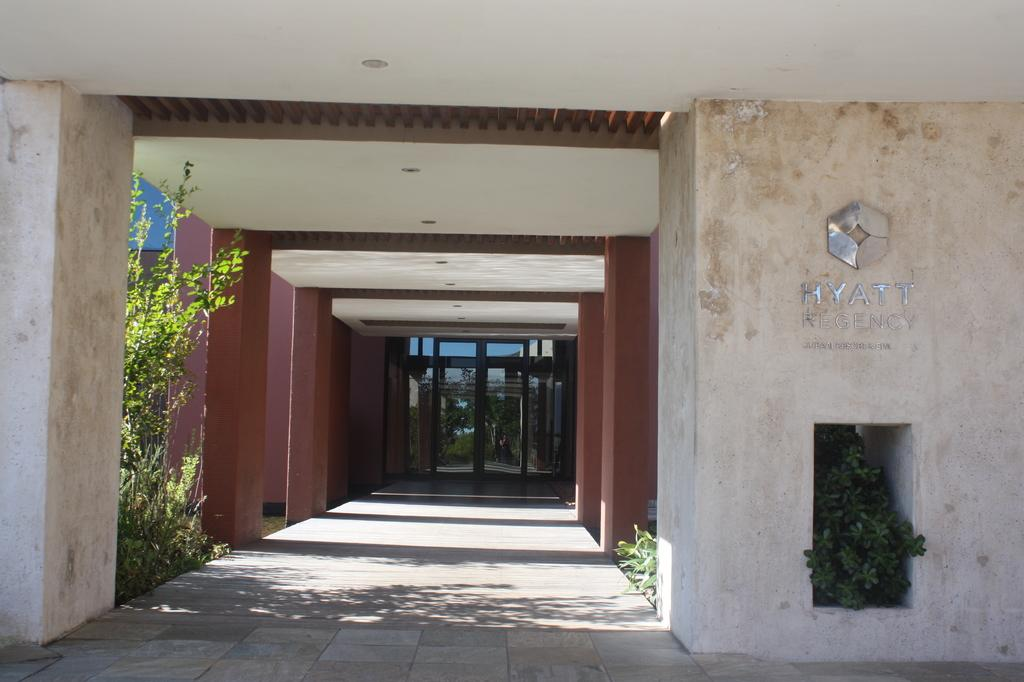What type of structure is present in the image? There is a building in the image. What architectural feature can be seen on the building? The building has pillars. What is located on either side of the building? There are plants on either side of the building. What type of door is present at the back of the building? There is a glass door at the back of the building. What type of shoe can be seen on the roof of the building in the image? There is no shoe present on the roof of the building in the image. 